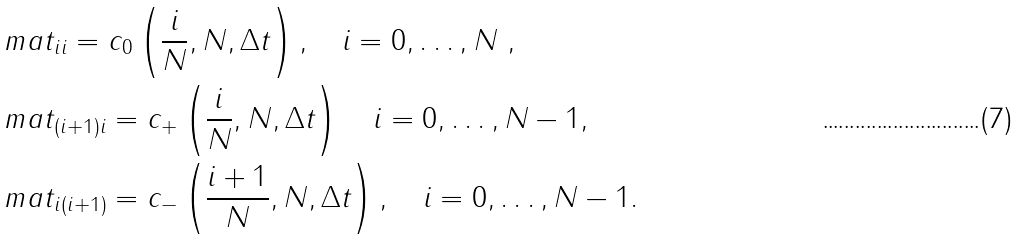<formula> <loc_0><loc_0><loc_500><loc_500>& \ m a t _ { i i } = c _ { 0 } \left ( \frac { i } { N } , N , \Delta t \right ) , \quad i = 0 , \dots , N \ , \\ & \ m a t _ { ( i + 1 ) i } = c _ { + } \left ( \frac { i } { N } , N , \Delta t \right ) \quad i = 0 , \dots , N - 1 , \\ & \ m a t _ { i ( i + 1 ) } = c _ { - } \left ( \frac { i + 1 } { N } , N , \Delta t \right ) , \quad i = 0 , \dots , N - 1 .</formula> 